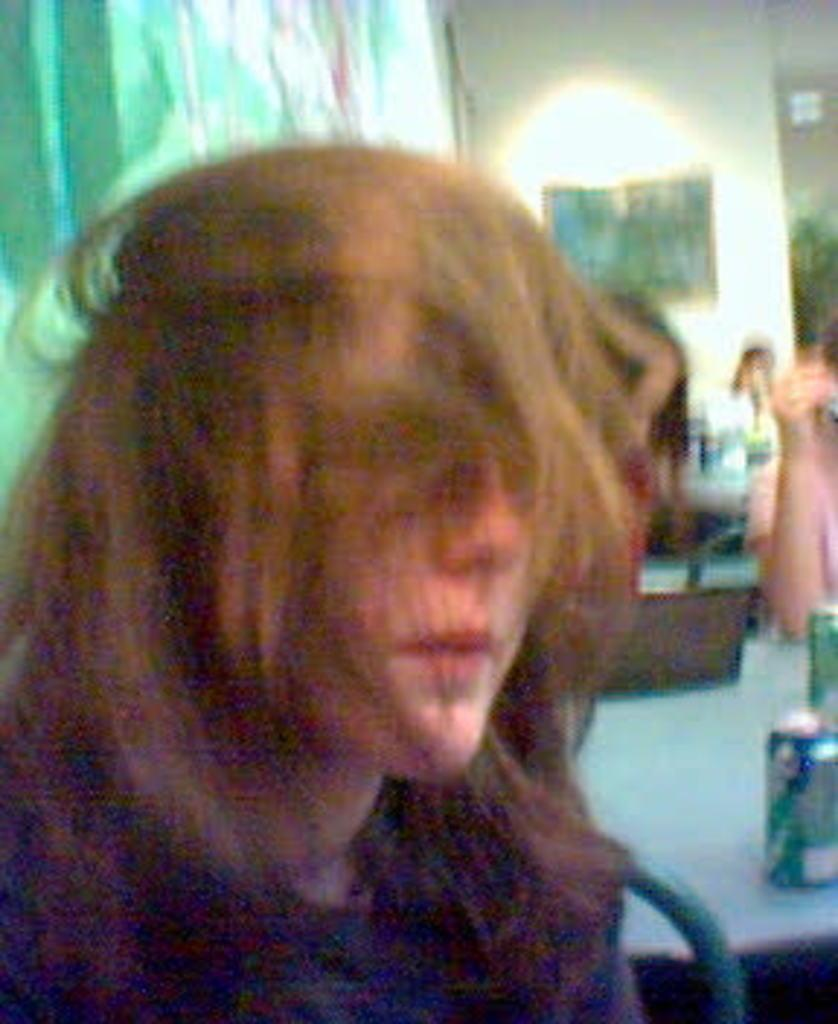What is the main subject of the image? There is a person in the image. Can you describe the background of the image? The background of the image is blurry, but a wall, a light, and a table are visible. What is attached to the wall in the background? There is a light attached to the wall in the background. What is on the table in the background? There are objects on the table in the background. Are there any other people visible in the image? Yes, there are other persons visible in the background. What type of potato is being used as a heart monitor in the image? There is no potato or heart monitor present in the image. 